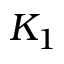<formula> <loc_0><loc_0><loc_500><loc_500>K _ { 1 }</formula> 